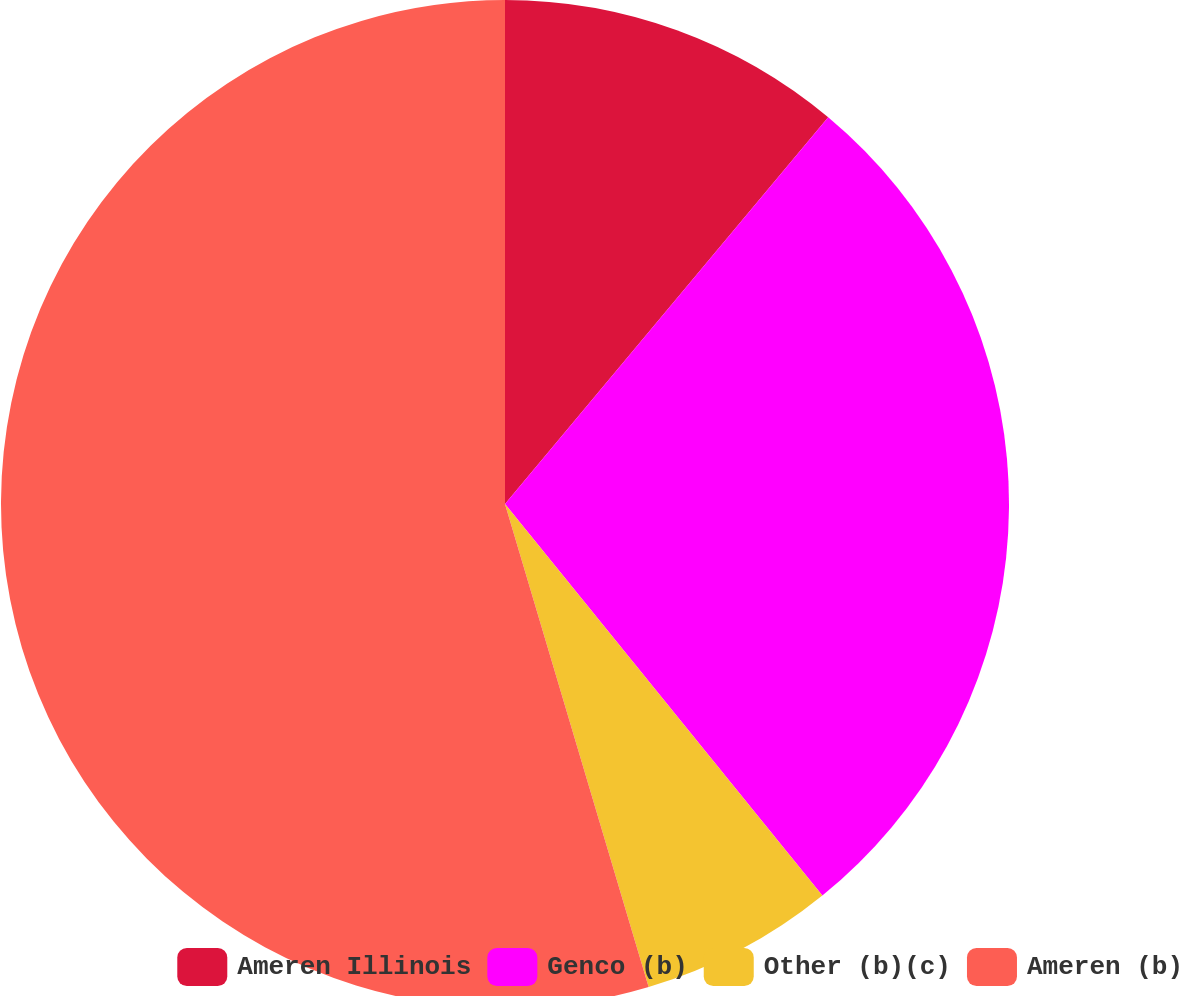Convert chart. <chart><loc_0><loc_0><loc_500><loc_500><pie_chart><fcel>Ameren Illinois<fcel>Genco (b)<fcel>Other (b)(c)<fcel>Ameren (b)<nl><fcel>11.08%<fcel>28.08%<fcel>6.24%<fcel>54.6%<nl></chart> 